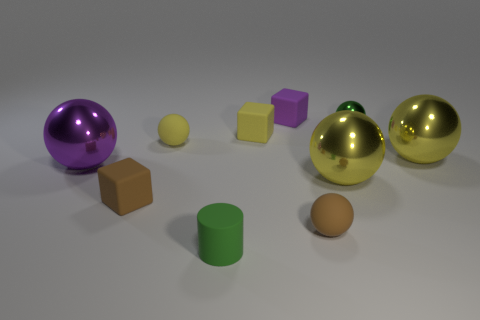What color is the matte ball that is to the left of the tiny purple matte block? yellow 